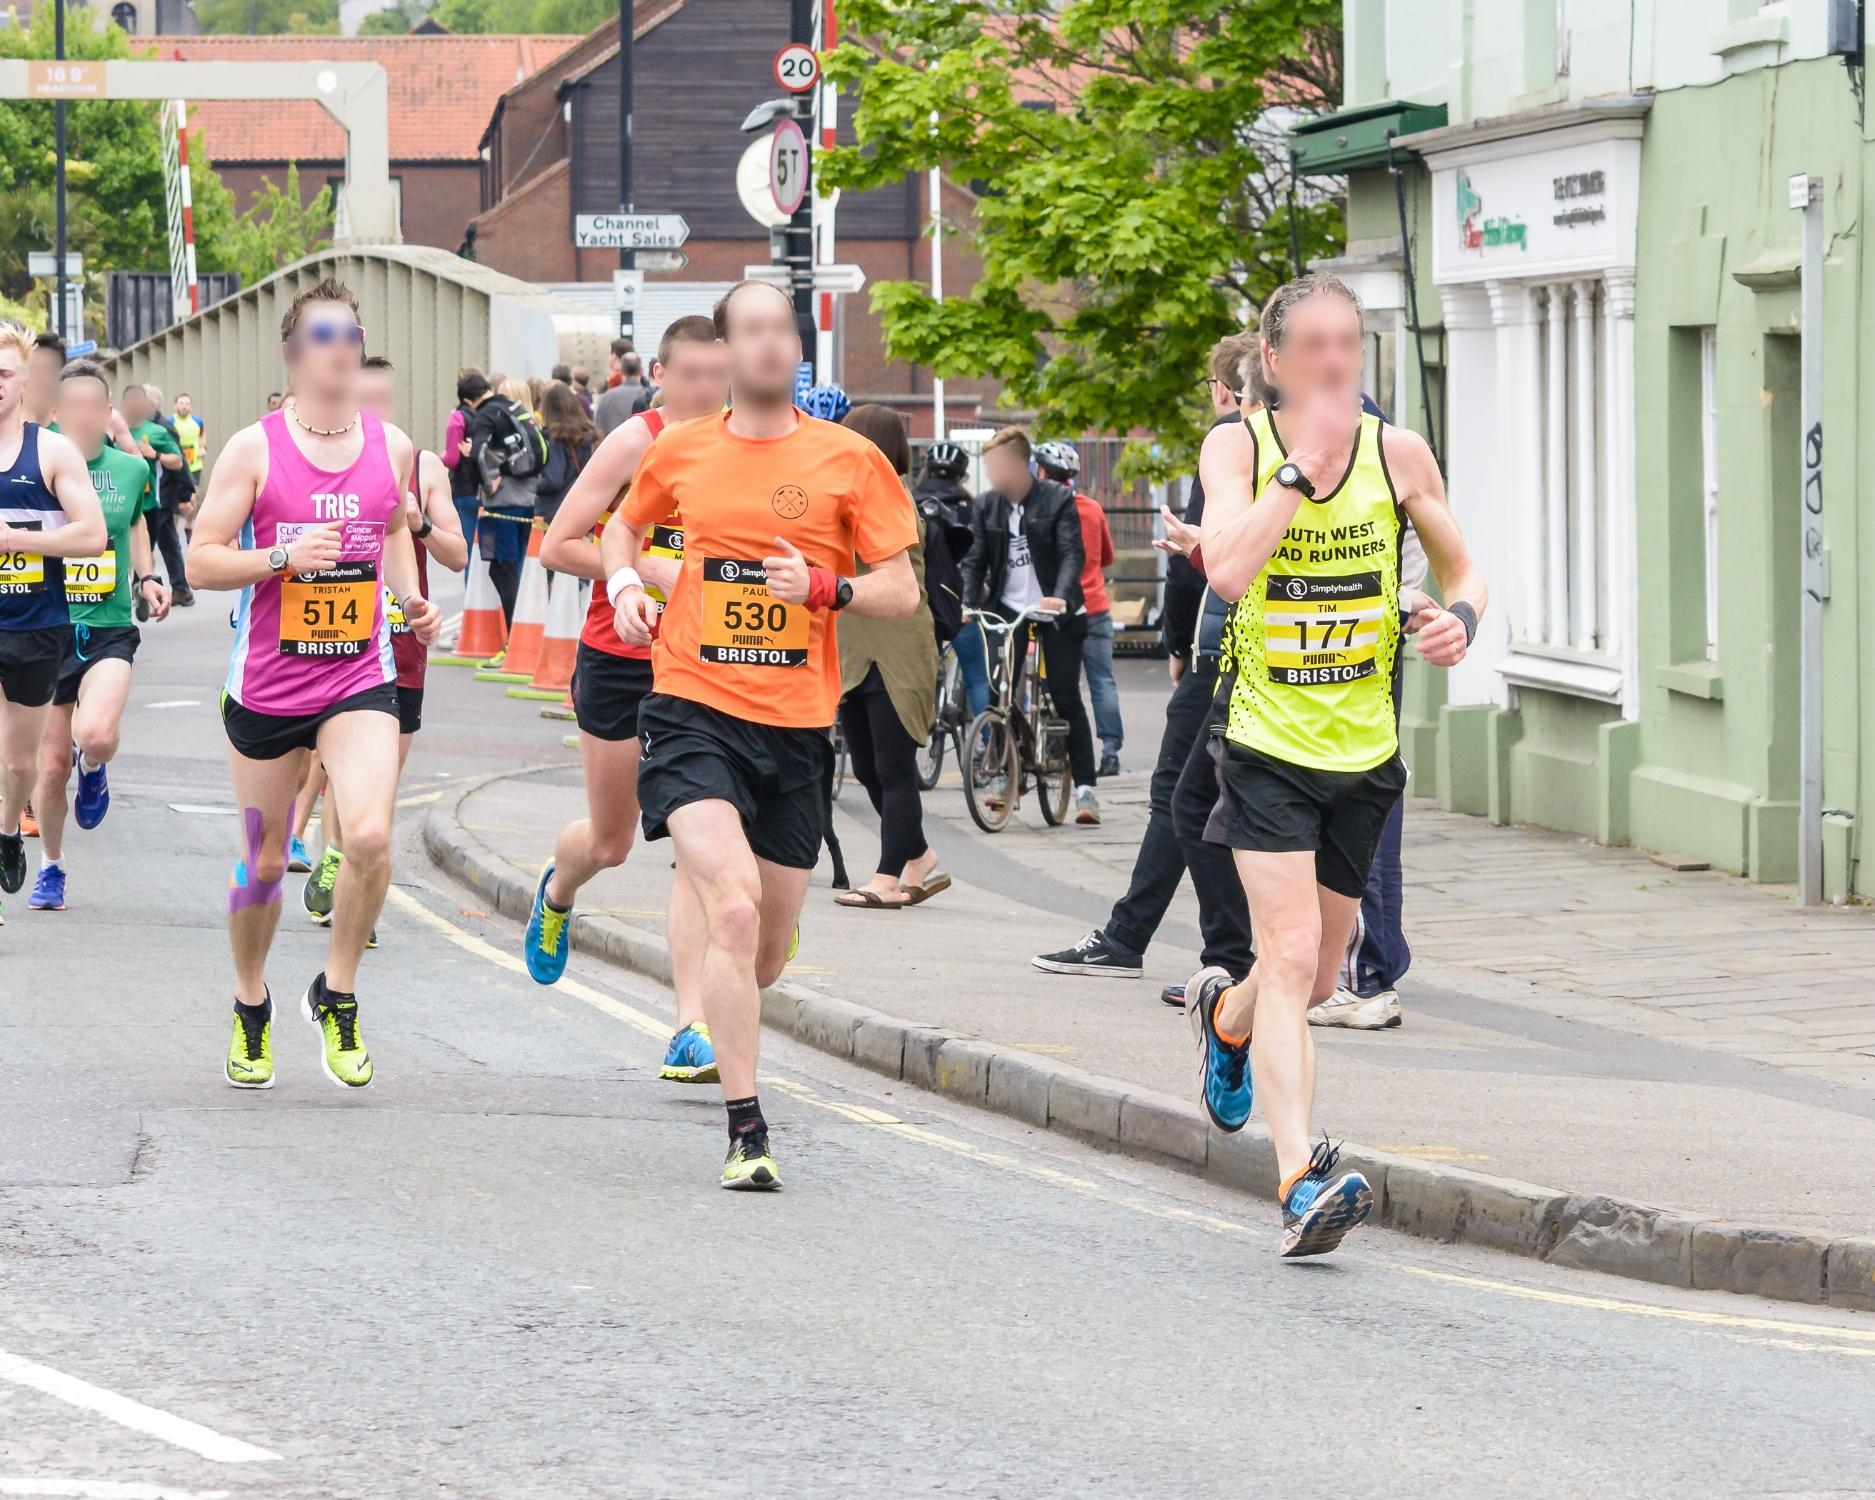Write a detailed description of the given image.
 The image captures a vibrant scene of a street race. A group of runners, adorned in colorful athletic clothes, are in mid-stride, their bibs with numbers fluttering against their chests. The energy of the race is palpable, with each runner focused on the path ahead. The buildings lining the street and a traffic sign in the background provide an urban backdrop to this athletic event. The low angle of the photo adds a dynamic perspective, emphasizing the motion and determination of the runners. The landmark identifier "sa_16623" doesn't provide any additional information about the location of the race. The image is a lively depiction of a community coming together in the spirit of competition and camaraderie. 